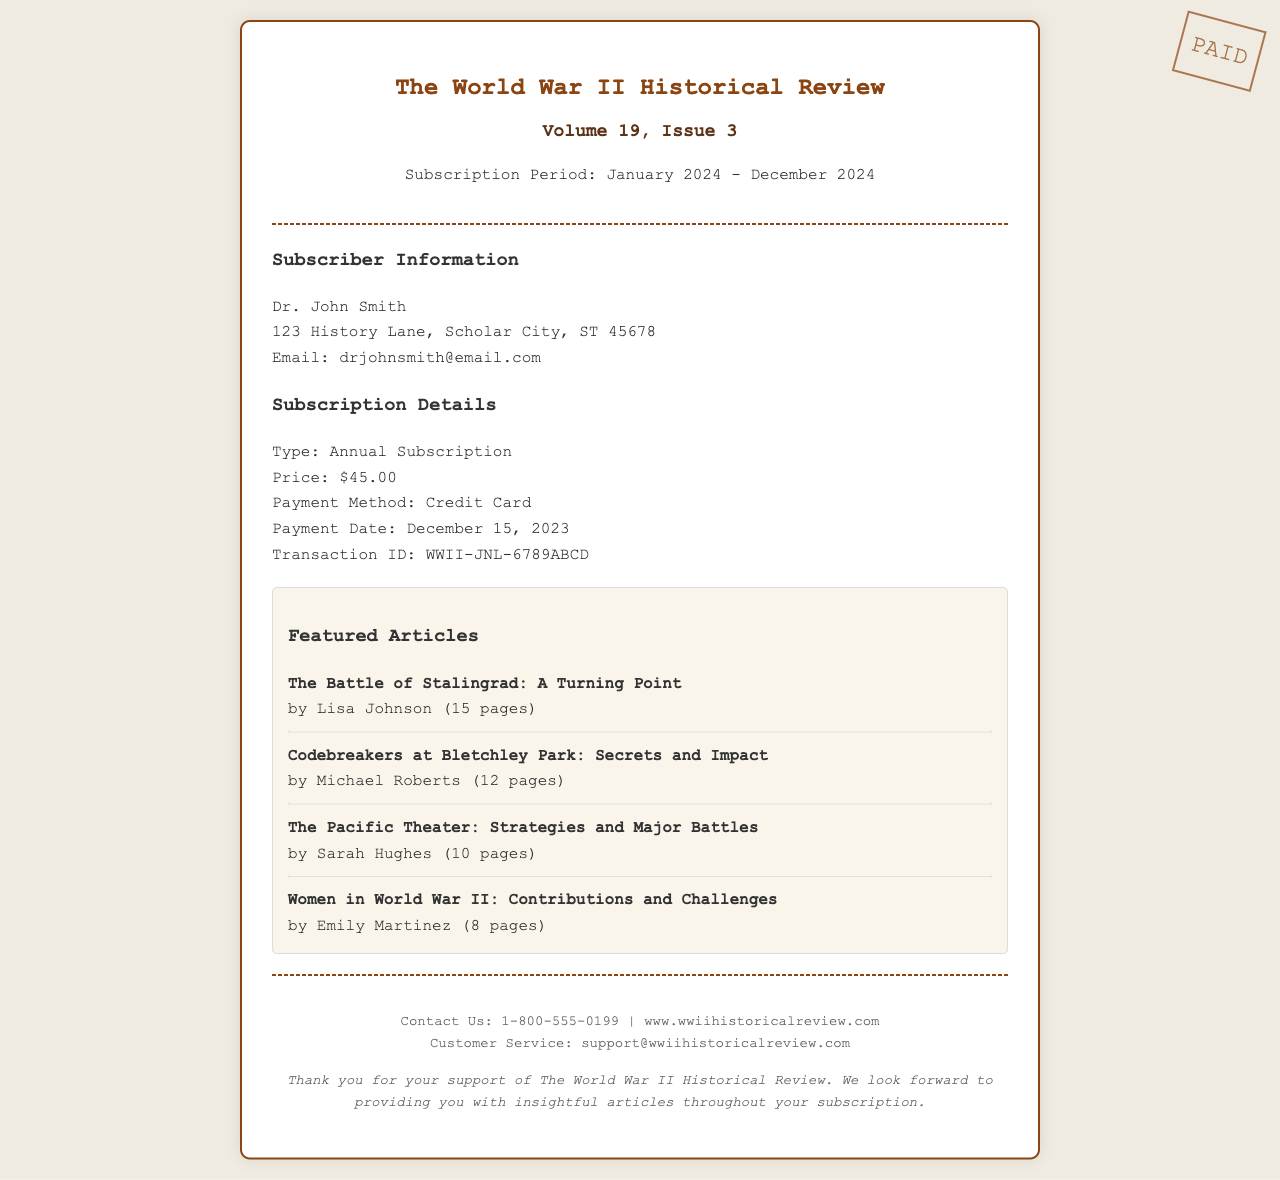What is the name of the journal? The journal's name is mentioned prominently in the header of the receipt.
Answer: The World War II Historical Review What is the subscription period? The receipt states the beginning and ending dates for the subscription period.
Answer: January 2024 - December 2024 Who is the subscriber? The subscriber's name is listed in the subscriber information section.
Answer: Dr. John Smith What is the type of subscription? The receipt specifies the category of the subscription in the subscription details.
Answer: Annual Subscription What is the price of the subscription? The price is highlighted in the subscription details section of the receipt.
Answer: $45.00 What payment method was used? The payment method is indicated in the subscription details section.
Answer: Credit Card When was the payment made? The payment date is presented in the subscription details area.
Answer: December 15, 2023 What is the transaction ID? The transaction ID is listed to confirm the payment details on the receipt.
Answer: WWII-JNL-6789ABCD How many featured articles are listed? To find the number of articles, one counts the featured articles presented in the document.
Answer: 4 